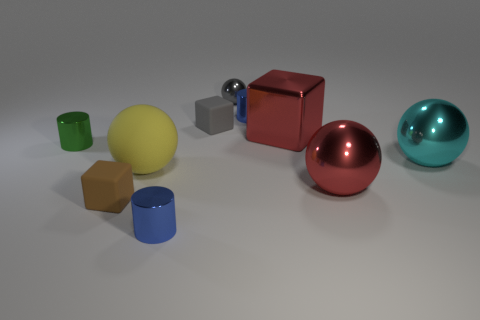Subtract all blue cylinders. Subtract all blue spheres. How many cylinders are left? 1 Subtract all cylinders. How many objects are left? 7 Add 7 red matte cylinders. How many red matte cylinders exist? 7 Subtract 0 green blocks. How many objects are left? 10 Subtract all small spheres. Subtract all tiny gray rubber cubes. How many objects are left? 8 Add 9 tiny gray rubber blocks. How many tiny gray rubber blocks are left? 10 